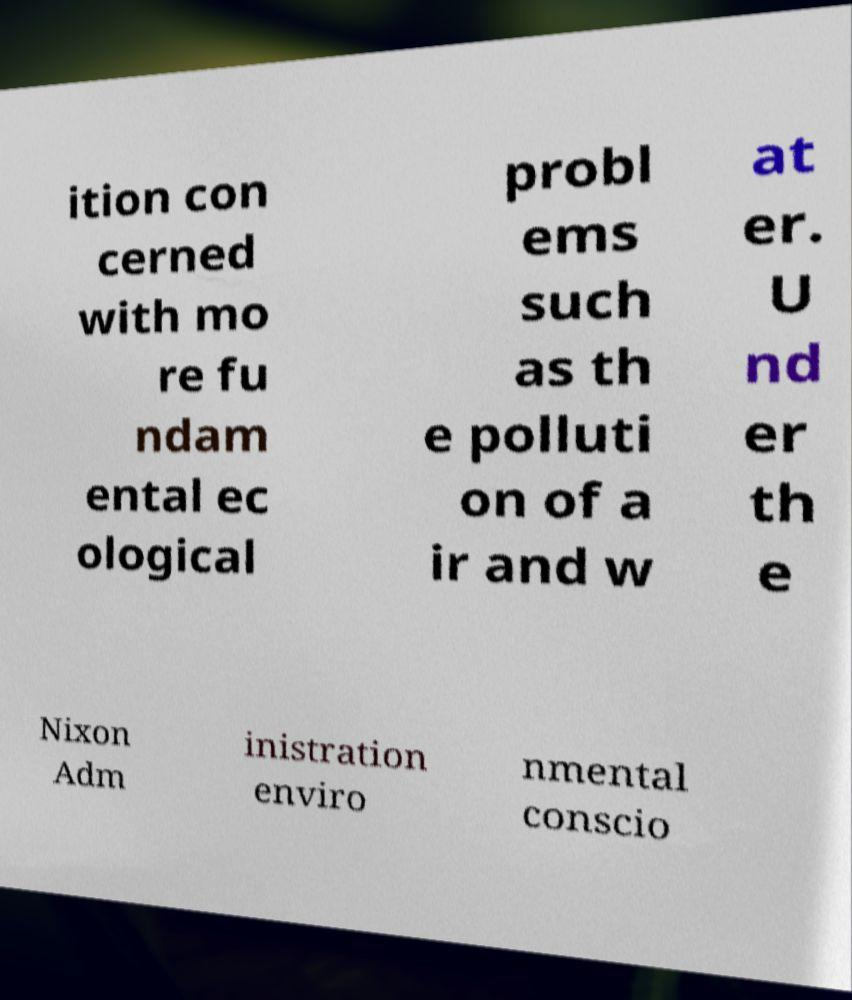There's text embedded in this image that I need extracted. Can you transcribe it verbatim? ition con cerned with mo re fu ndam ental ec ological probl ems such as th e polluti on of a ir and w at er. U nd er th e Nixon Adm inistration enviro nmental conscio 